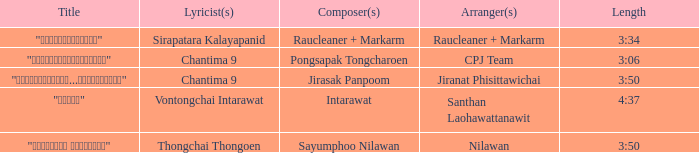Who was the arranger of "ขอโทษ"? Santhan Laohawattanawit. 